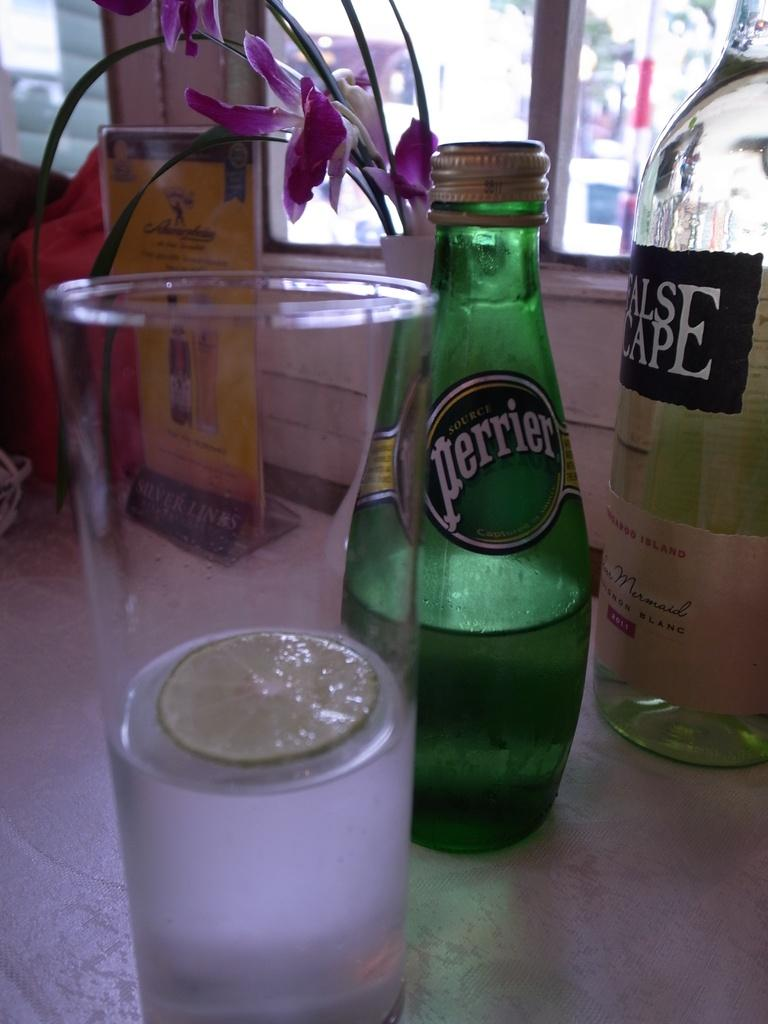What objects can be seen on the table in the image? There are bottles and a glass with liquid and lemon on the table in the image. What else is visible in the image besides the table? There is a board, flowers, and a glass window visible in the image. Are there any stockings hanging from the board in the image? There is no mention of stockings in the image, and they are not visible in the provided facts. 